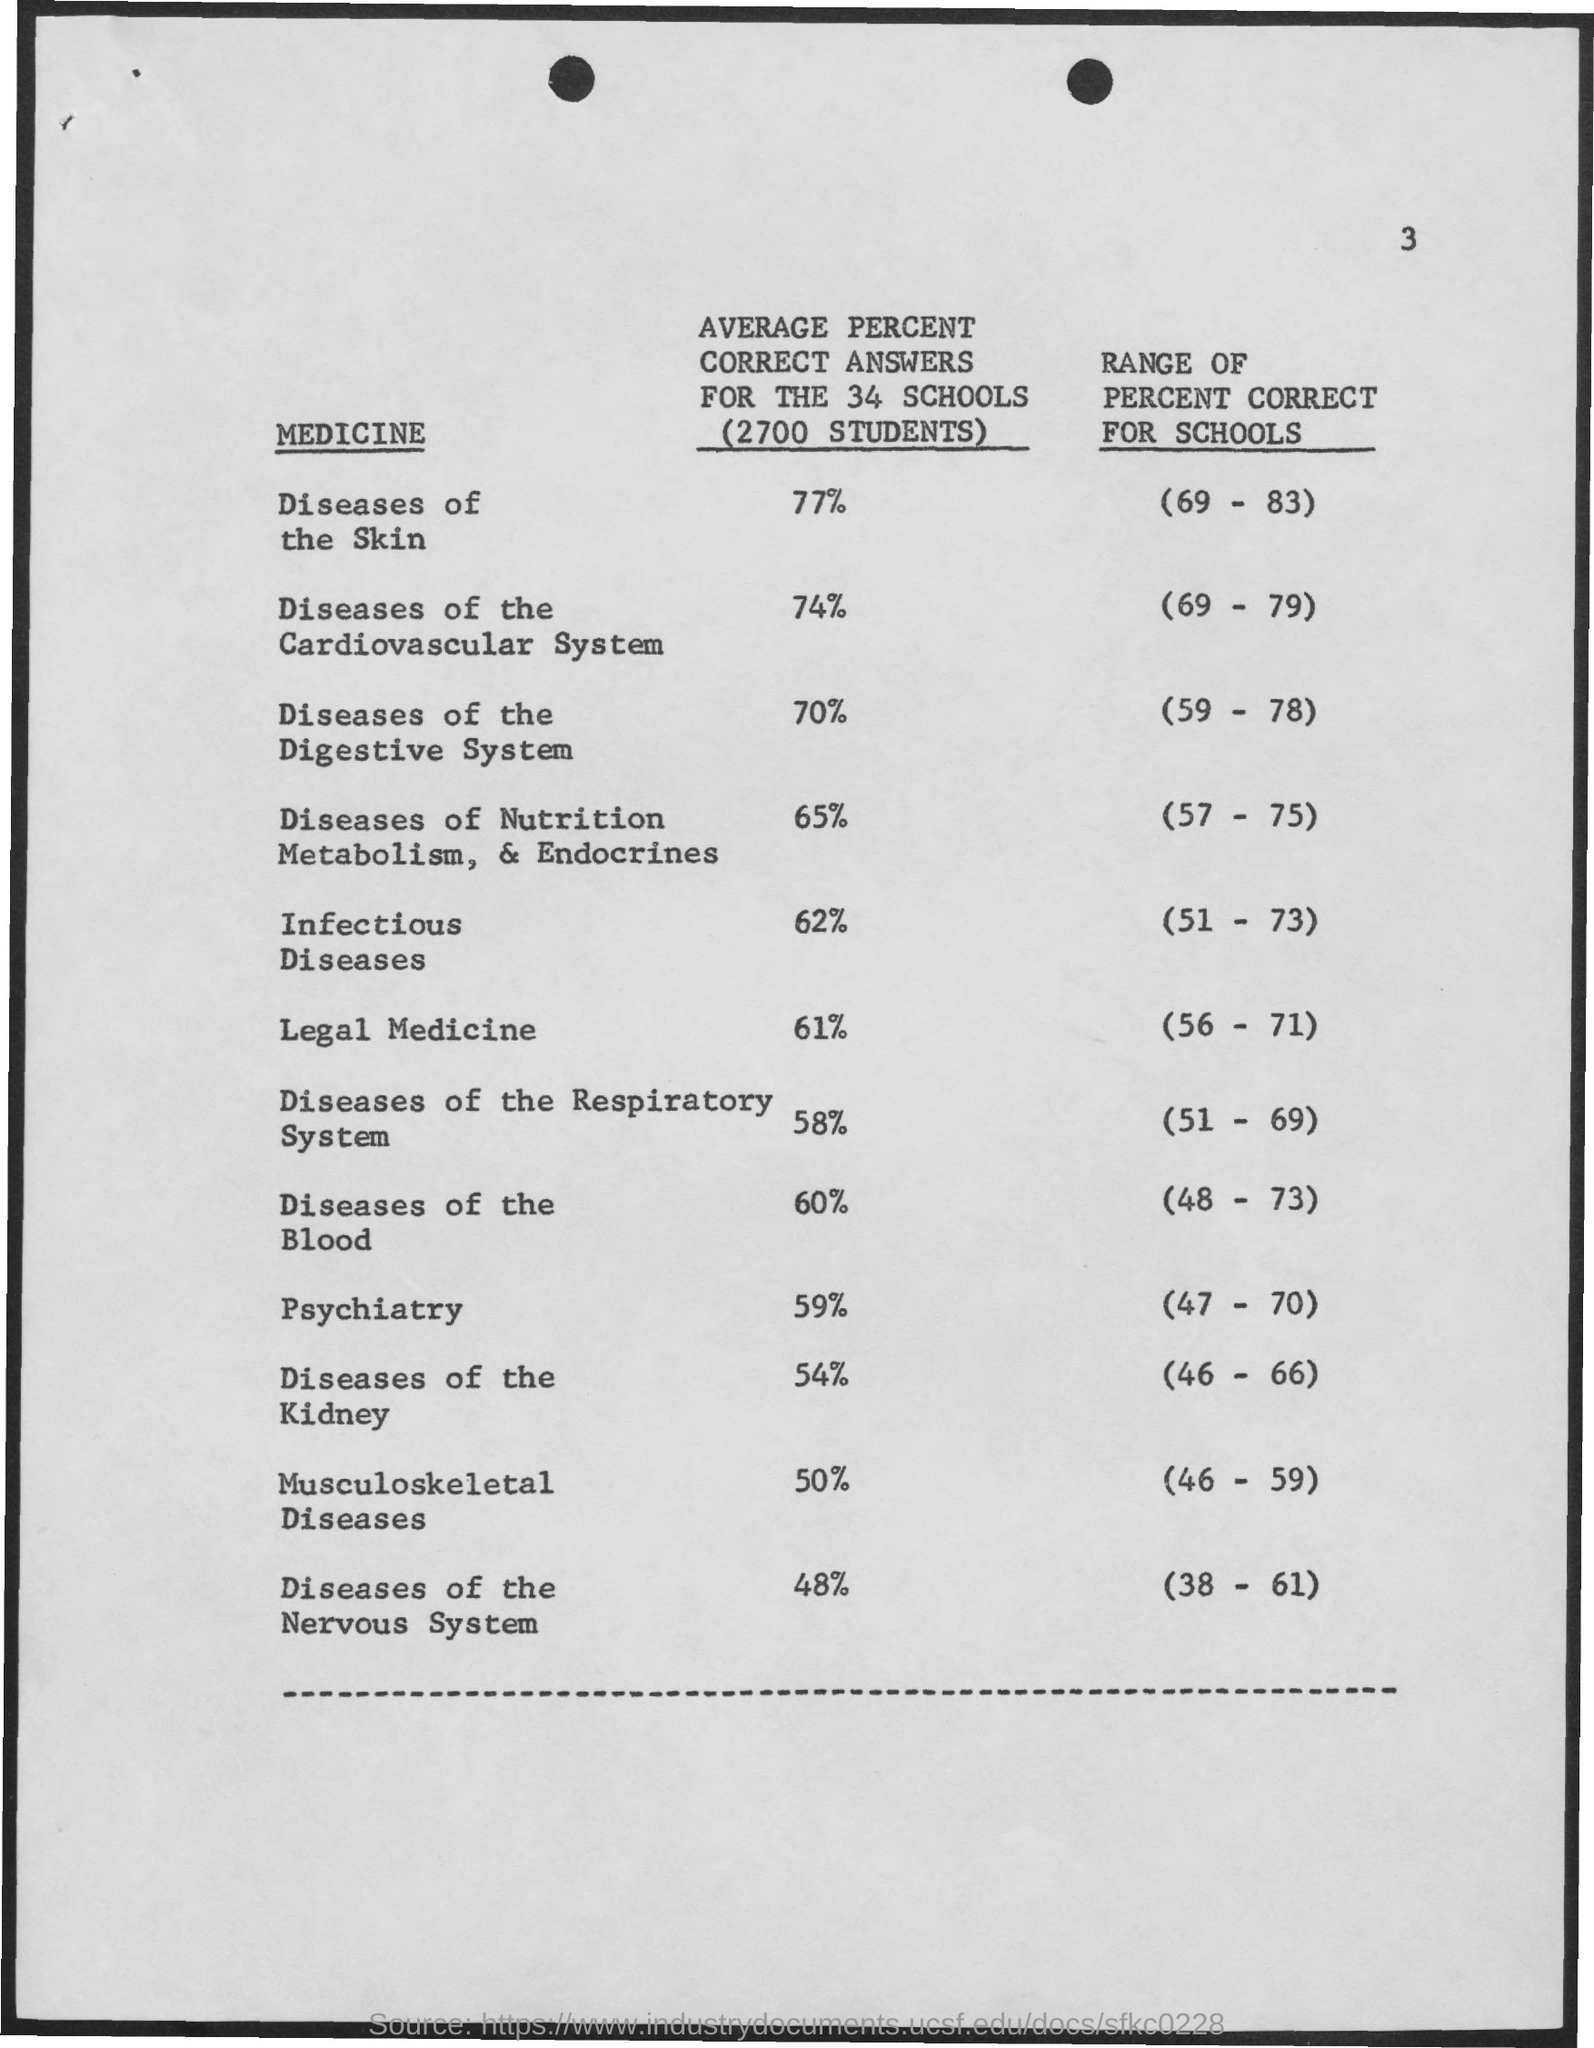What is the number of schools?
Make the answer very short. 34. What is the number of students?
Your response must be concise. 2700. 